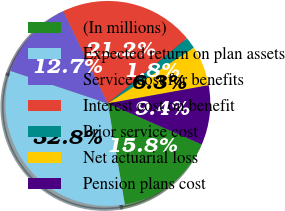<chart> <loc_0><loc_0><loc_500><loc_500><pie_chart><fcel>(In millions)<fcel>Expected return on plan assets<fcel>Service cost for benefits<fcel>Interest cost on benefit<fcel>Prior service cost<fcel>Net actuarial loss<fcel>Pension plans cost<nl><fcel>15.8%<fcel>32.79%<fcel>12.7%<fcel>21.21%<fcel>1.82%<fcel>6.29%<fcel>9.39%<nl></chart> 